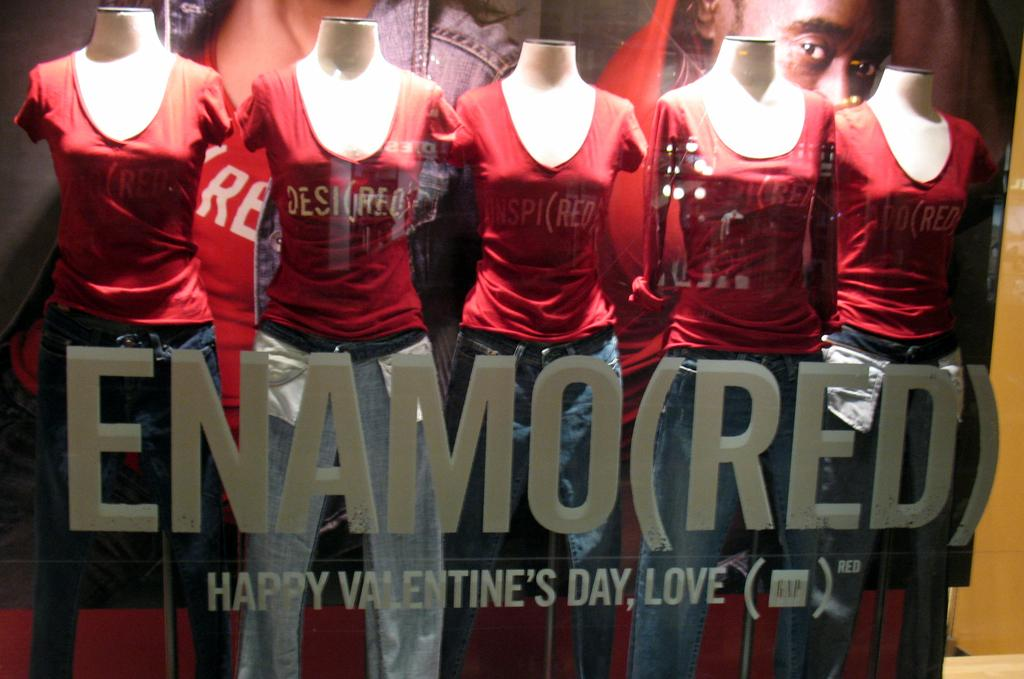<image>
Provide a brief description of the given image. a group of mannequins sit next to each other as it reads enamored 